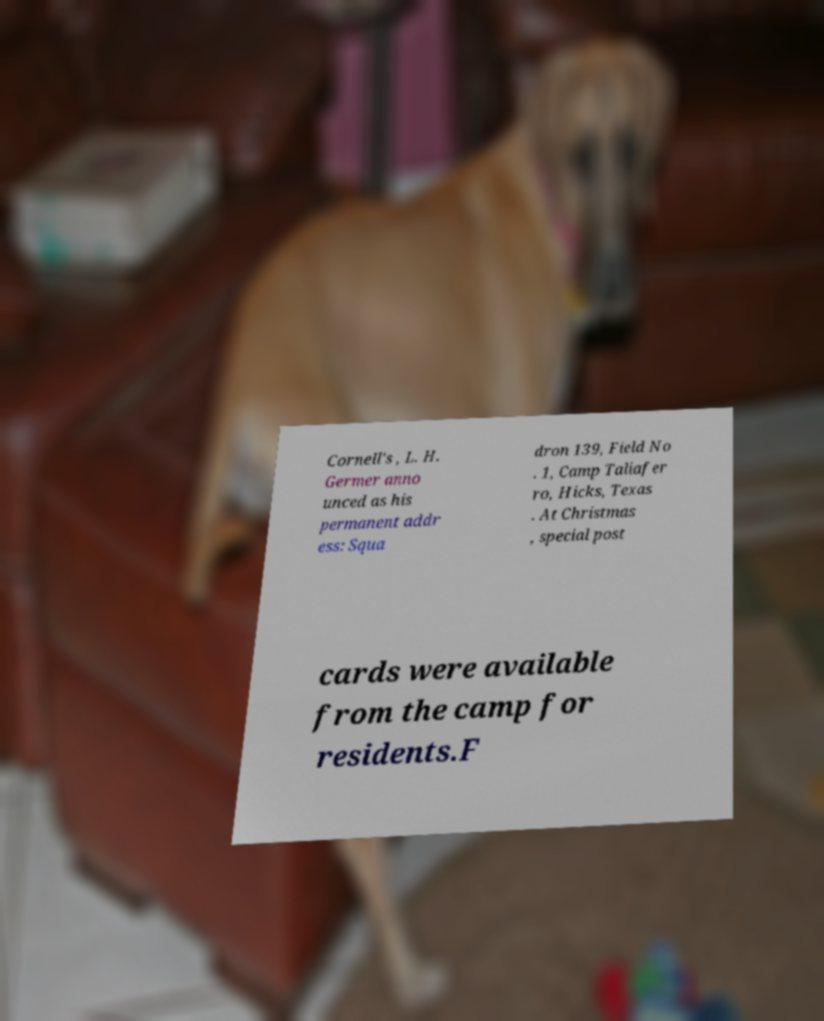Could you assist in decoding the text presented in this image and type it out clearly? Cornell's , L. H. Germer anno unced as his permanent addr ess: Squa dron 139, Field No . 1, Camp Taliafer ro, Hicks, Texas . At Christmas , special post cards were available from the camp for residents.F 